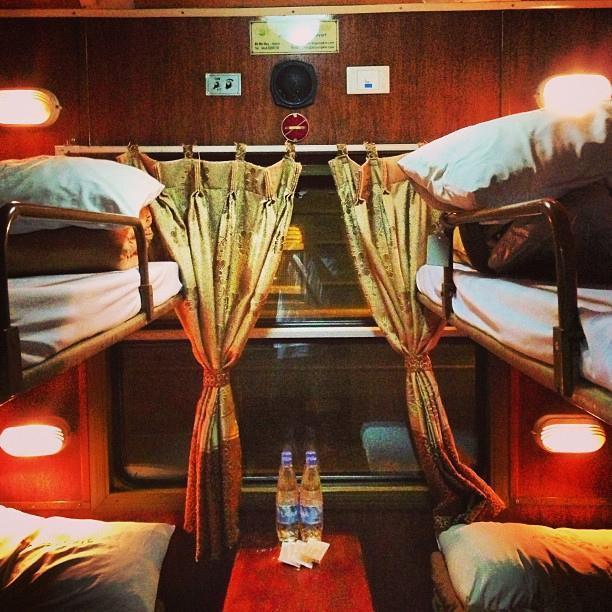How many lights are in this room?
Give a very brief answer. 5. How many bunks are there?
Give a very brief answer. 4. How many beds are visible?
Give a very brief answer. 4. 